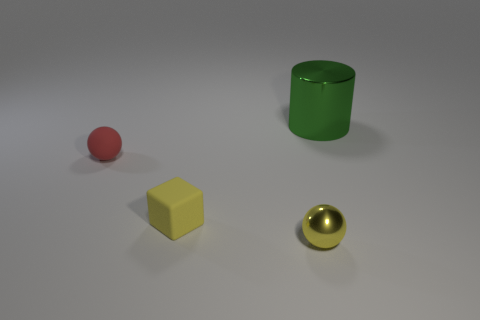There is a tiny thing in front of the small yellow matte object; is it the same color as the large shiny thing?
Provide a short and direct response. No. Are there any tiny yellow cubes behind the small red rubber object?
Offer a terse response. No. The object that is behind the yellow rubber thing and in front of the big green metallic cylinder is what color?
Ensure brevity in your answer.  Red. What shape is the object that is the same color as the tiny metal ball?
Your answer should be compact. Cube. There is a metallic thing to the left of the metallic object on the right side of the yellow sphere; how big is it?
Keep it short and to the point. Small. What number of cylinders are either large cyan metallic things or green metallic objects?
Give a very brief answer. 1. There is a rubber ball that is the same size as the yellow shiny thing; what color is it?
Your answer should be compact. Red. There is a thing that is to the right of the shiny thing in front of the large green metallic thing; what shape is it?
Provide a succinct answer. Cylinder. There is a shiny object in front of the metallic cylinder; does it have the same size as the rubber ball?
Ensure brevity in your answer.  Yes. How many other objects are there of the same material as the big cylinder?
Make the answer very short. 1. 